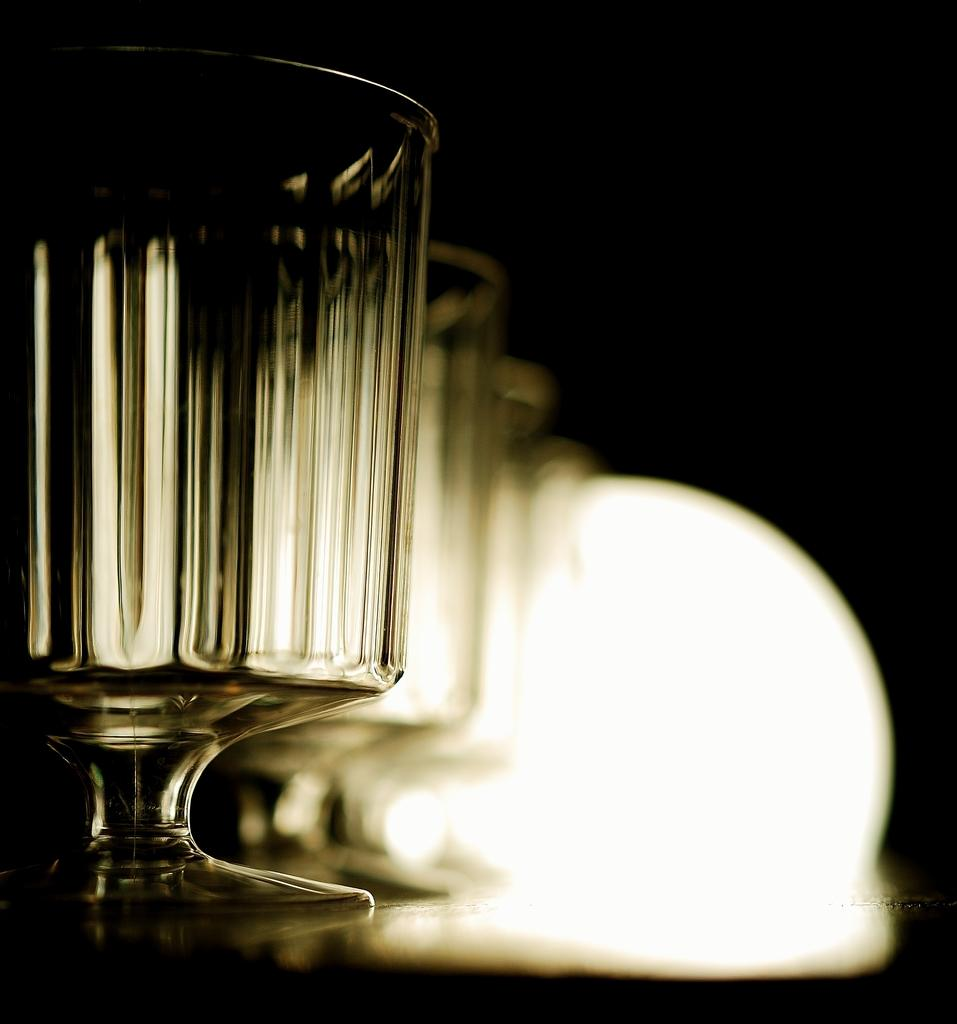What objects can be seen in the image? There are glasses and a light in the image. Can you describe the background of the image? The background of the image is dark. How many rabbits can be seen in the image? There are no rabbits present in the image. What is the income of the person in the image? There is no person present in the image, so it is not possible to determine their income. 